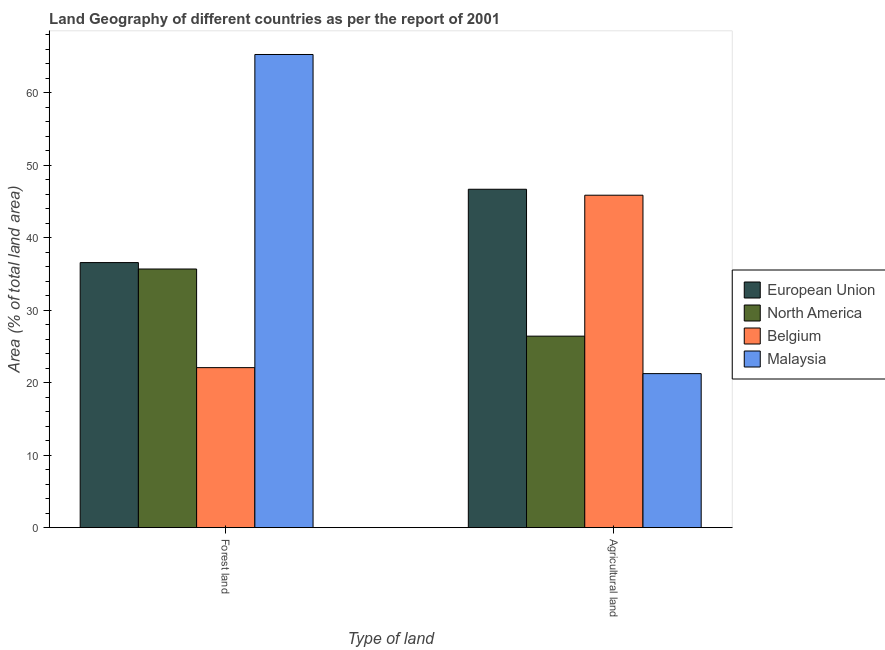How many different coloured bars are there?
Your answer should be compact. 4. How many bars are there on the 2nd tick from the left?
Keep it short and to the point. 4. What is the label of the 2nd group of bars from the left?
Your answer should be compact. Agricultural land. What is the percentage of land area under agriculture in North America?
Make the answer very short. 26.43. Across all countries, what is the maximum percentage of land area under forests?
Your answer should be compact. 65.29. Across all countries, what is the minimum percentage of land area under agriculture?
Give a very brief answer. 21.26. In which country was the percentage of land area under agriculture maximum?
Your answer should be very brief. European Union. In which country was the percentage of land area under forests minimum?
Keep it short and to the point. Belgium. What is the total percentage of land area under agriculture in the graph?
Keep it short and to the point. 140.25. What is the difference between the percentage of land area under agriculture in European Union and that in North America?
Your answer should be very brief. 20.27. What is the difference between the percentage of land area under forests in European Union and the percentage of land area under agriculture in Belgium?
Your answer should be compact. -9.29. What is the average percentage of land area under forests per country?
Your answer should be very brief. 39.91. What is the difference between the percentage of land area under agriculture and percentage of land area under forests in European Union?
Your response must be concise. 10.12. In how many countries, is the percentage of land area under agriculture greater than 48 %?
Your answer should be very brief. 0. What is the ratio of the percentage of land area under agriculture in North America to that in Malaysia?
Your answer should be compact. 1.24. What does the 4th bar from the left in Forest land represents?
Offer a very short reply. Malaysia. Are all the bars in the graph horizontal?
Offer a terse response. No. How many countries are there in the graph?
Your response must be concise. 4. Does the graph contain grids?
Provide a succinct answer. No. What is the title of the graph?
Keep it short and to the point. Land Geography of different countries as per the report of 2001. What is the label or title of the X-axis?
Provide a short and direct response. Type of land. What is the label or title of the Y-axis?
Ensure brevity in your answer.  Area (% of total land area). What is the Area (% of total land area) in European Union in Forest land?
Offer a terse response. 36.58. What is the Area (% of total land area) of North America in Forest land?
Keep it short and to the point. 35.69. What is the Area (% of total land area) of Belgium in Forest land?
Ensure brevity in your answer.  22.08. What is the Area (% of total land area) in Malaysia in Forest land?
Offer a terse response. 65.29. What is the Area (% of total land area) in European Union in Agricultural land?
Give a very brief answer. 46.69. What is the Area (% of total land area) of North America in Agricultural land?
Your answer should be compact. 26.43. What is the Area (% of total land area) in Belgium in Agricultural land?
Your answer should be very brief. 45.87. What is the Area (% of total land area) in Malaysia in Agricultural land?
Ensure brevity in your answer.  21.26. Across all Type of land, what is the maximum Area (% of total land area) in European Union?
Give a very brief answer. 46.69. Across all Type of land, what is the maximum Area (% of total land area) in North America?
Your answer should be compact. 35.69. Across all Type of land, what is the maximum Area (% of total land area) of Belgium?
Give a very brief answer. 45.87. Across all Type of land, what is the maximum Area (% of total land area) in Malaysia?
Your response must be concise. 65.29. Across all Type of land, what is the minimum Area (% of total land area) in European Union?
Your answer should be compact. 36.58. Across all Type of land, what is the minimum Area (% of total land area) in North America?
Offer a very short reply. 26.43. Across all Type of land, what is the minimum Area (% of total land area) of Belgium?
Your answer should be very brief. 22.08. Across all Type of land, what is the minimum Area (% of total land area) in Malaysia?
Offer a very short reply. 21.26. What is the total Area (% of total land area) in European Union in the graph?
Your answer should be very brief. 83.27. What is the total Area (% of total land area) of North America in the graph?
Your answer should be compact. 62.12. What is the total Area (% of total land area) of Belgium in the graph?
Ensure brevity in your answer.  67.96. What is the total Area (% of total land area) of Malaysia in the graph?
Ensure brevity in your answer.  86.55. What is the difference between the Area (% of total land area) of European Union in Forest land and that in Agricultural land?
Provide a succinct answer. -10.12. What is the difference between the Area (% of total land area) in North America in Forest land and that in Agricultural land?
Ensure brevity in your answer.  9.26. What is the difference between the Area (% of total land area) in Belgium in Forest land and that in Agricultural land?
Keep it short and to the point. -23.79. What is the difference between the Area (% of total land area) in Malaysia in Forest land and that in Agricultural land?
Keep it short and to the point. 44.03. What is the difference between the Area (% of total land area) of European Union in Forest land and the Area (% of total land area) of North America in Agricultural land?
Your answer should be very brief. 10.15. What is the difference between the Area (% of total land area) in European Union in Forest land and the Area (% of total land area) in Belgium in Agricultural land?
Offer a terse response. -9.29. What is the difference between the Area (% of total land area) of European Union in Forest land and the Area (% of total land area) of Malaysia in Agricultural land?
Keep it short and to the point. 15.32. What is the difference between the Area (% of total land area) of North America in Forest land and the Area (% of total land area) of Belgium in Agricultural land?
Ensure brevity in your answer.  -10.18. What is the difference between the Area (% of total land area) in North America in Forest land and the Area (% of total land area) in Malaysia in Agricultural land?
Keep it short and to the point. 14.43. What is the difference between the Area (% of total land area) of Belgium in Forest land and the Area (% of total land area) of Malaysia in Agricultural land?
Make the answer very short. 0.83. What is the average Area (% of total land area) of European Union per Type of land?
Keep it short and to the point. 41.64. What is the average Area (% of total land area) in North America per Type of land?
Your response must be concise. 31.06. What is the average Area (% of total land area) in Belgium per Type of land?
Offer a terse response. 33.98. What is the average Area (% of total land area) in Malaysia per Type of land?
Keep it short and to the point. 43.27. What is the difference between the Area (% of total land area) of European Union and Area (% of total land area) of North America in Forest land?
Make the answer very short. 0.89. What is the difference between the Area (% of total land area) of European Union and Area (% of total land area) of Belgium in Forest land?
Ensure brevity in your answer.  14.49. What is the difference between the Area (% of total land area) in European Union and Area (% of total land area) in Malaysia in Forest land?
Keep it short and to the point. -28.71. What is the difference between the Area (% of total land area) in North America and Area (% of total land area) in Belgium in Forest land?
Provide a short and direct response. 13.61. What is the difference between the Area (% of total land area) in North America and Area (% of total land area) in Malaysia in Forest land?
Ensure brevity in your answer.  -29.6. What is the difference between the Area (% of total land area) of Belgium and Area (% of total land area) of Malaysia in Forest land?
Offer a very short reply. -43.21. What is the difference between the Area (% of total land area) of European Union and Area (% of total land area) of North America in Agricultural land?
Make the answer very short. 20.27. What is the difference between the Area (% of total land area) of European Union and Area (% of total land area) of Belgium in Agricultural land?
Your answer should be compact. 0.82. What is the difference between the Area (% of total land area) of European Union and Area (% of total land area) of Malaysia in Agricultural land?
Your response must be concise. 25.44. What is the difference between the Area (% of total land area) in North America and Area (% of total land area) in Belgium in Agricultural land?
Your answer should be very brief. -19.44. What is the difference between the Area (% of total land area) of North America and Area (% of total land area) of Malaysia in Agricultural land?
Ensure brevity in your answer.  5.17. What is the difference between the Area (% of total land area) of Belgium and Area (% of total land area) of Malaysia in Agricultural land?
Give a very brief answer. 24.62. What is the ratio of the Area (% of total land area) of European Union in Forest land to that in Agricultural land?
Offer a terse response. 0.78. What is the ratio of the Area (% of total land area) of North America in Forest land to that in Agricultural land?
Your answer should be compact. 1.35. What is the ratio of the Area (% of total land area) of Belgium in Forest land to that in Agricultural land?
Make the answer very short. 0.48. What is the ratio of the Area (% of total land area) of Malaysia in Forest land to that in Agricultural land?
Ensure brevity in your answer.  3.07. What is the difference between the highest and the second highest Area (% of total land area) of European Union?
Ensure brevity in your answer.  10.12. What is the difference between the highest and the second highest Area (% of total land area) in North America?
Make the answer very short. 9.26. What is the difference between the highest and the second highest Area (% of total land area) in Belgium?
Your answer should be very brief. 23.79. What is the difference between the highest and the second highest Area (% of total land area) of Malaysia?
Offer a very short reply. 44.03. What is the difference between the highest and the lowest Area (% of total land area) of European Union?
Provide a succinct answer. 10.12. What is the difference between the highest and the lowest Area (% of total land area) in North America?
Your response must be concise. 9.26. What is the difference between the highest and the lowest Area (% of total land area) of Belgium?
Your response must be concise. 23.79. What is the difference between the highest and the lowest Area (% of total land area) of Malaysia?
Ensure brevity in your answer.  44.03. 